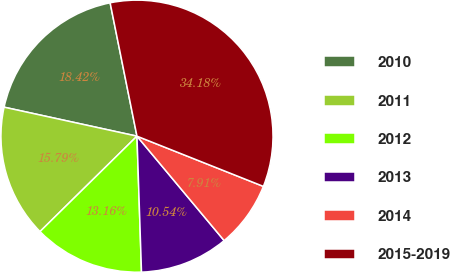Convert chart to OTSL. <chart><loc_0><loc_0><loc_500><loc_500><pie_chart><fcel>2010<fcel>2011<fcel>2012<fcel>2013<fcel>2014<fcel>2015-2019<nl><fcel>18.42%<fcel>15.79%<fcel>13.16%<fcel>10.54%<fcel>7.91%<fcel>34.18%<nl></chart> 